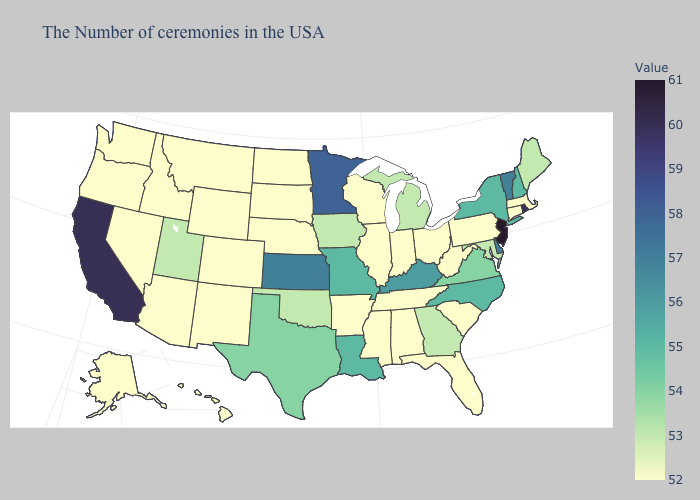Among the states that border Maine , which have the lowest value?
Write a very short answer. New Hampshire. Does New Jersey have the highest value in the USA?
Be succinct. Yes. Which states have the lowest value in the Northeast?
Keep it brief. Massachusetts, Connecticut, Pennsylvania. Among the states that border Utah , which have the lowest value?
Give a very brief answer. Wyoming, Colorado, New Mexico, Arizona, Idaho, Nevada. Is the legend a continuous bar?
Write a very short answer. Yes. 